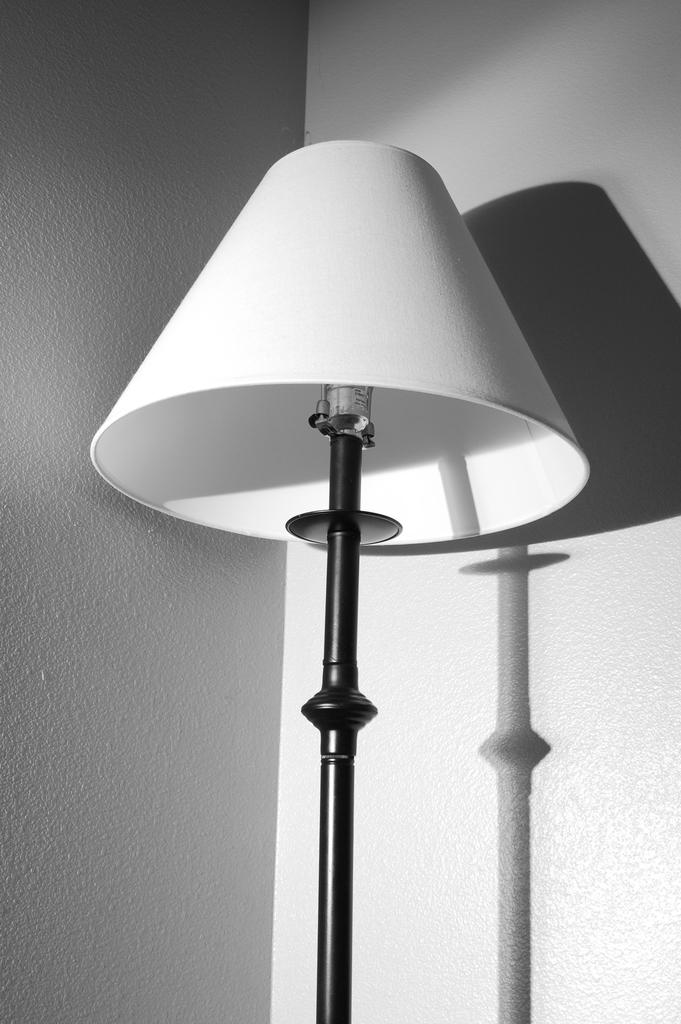What is the color scheme of the image? The image is black and white. What object can be seen in the image? There is a lamp in the image. What effect does the lamp have on the background of the image? The shadow of the lamp is visible on the wall in the background. What year is depicted in the image? The image does not depict a specific year; it is a black and white image with a lamp and its shadow on the wall. What type of trade is being conducted in the image? There is no trade being conducted in the image; it features a lamp and its shadow on the wall. 